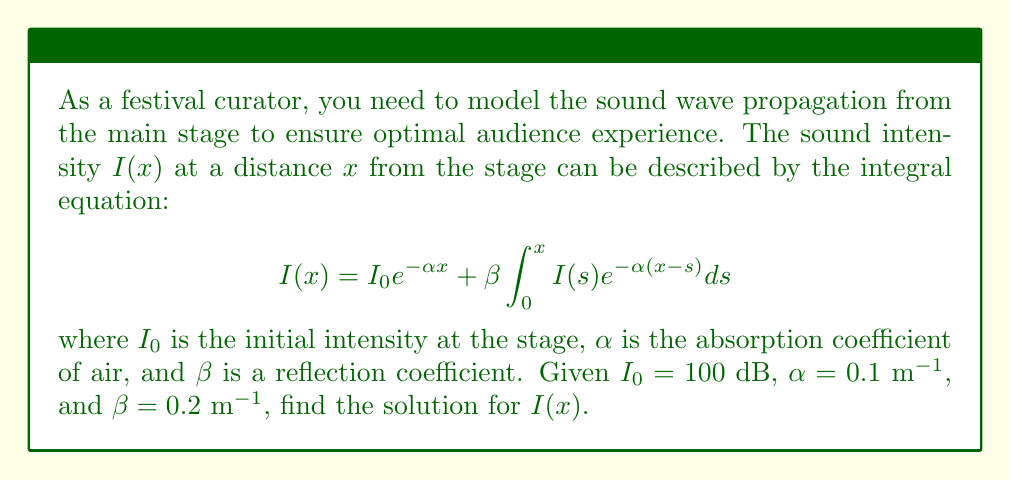Can you answer this question? To solve this integral equation, we'll follow these steps:

1) First, we recognize this as a Volterra integral equation of the second kind. The general form is:

   $$y(x) = f(x) + \lambda \int_a^x K(x,t)y(t)dt$$

   In our case, $f(x) = I_0 e^{-\alpha x}$, $\lambda = \beta$, and $K(x,t) = e^{-\alpha(x-t)}$.

2) For Volterra equations of this form, we can use the method of successive approximations. Let's start with $I_0(x) = I_0 e^{-\alpha x}$.

3) The next approximation would be:

   $$I_1(x) = I_0 e^{-\alpha x} + \beta \int_0^x I_0 e^{-\alpha s} e^{-\alpha(x-s)} ds$$

4) Simplifying the integral:

   $$I_1(x) = I_0 e^{-\alpha x} + \beta I_0 \int_0^x e^{-\alpha x} ds = I_0 e^{-\alpha x} + \beta I_0 x e^{-\alpha x}$$

5) The general solution for this type of equation is of the form:

   $$I(x) = I_0 e^{-\alpha x} (1 + \beta x + \frac{(\beta x)^2}{2!} + \frac{(\beta x)^3}{3!} + ...)$$

6) This series can be recognized as the Taylor series for $e^{\beta x}$. Therefore, the solution is:

   $$I(x) = I_0 e^{-\alpha x} e^{\beta x} = I_0 e^{(\beta - \alpha)x}$$

7) Substituting the given values:

   $$I(x) = 100 e^{(0.2 - 0.1)x} = 100 e^{0.1x}$$
Answer: $I(x) = 100 e^{0.1x}$ dB 